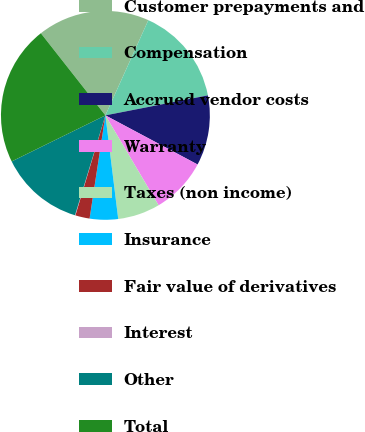Convert chart to OTSL. <chart><loc_0><loc_0><loc_500><loc_500><pie_chart><fcel>Customer prepayments and<fcel>Compensation<fcel>Accrued vendor costs<fcel>Warranty<fcel>Taxes (non income)<fcel>Insurance<fcel>Fair value of derivatives<fcel>Interest<fcel>Other<fcel>Total<nl><fcel>17.34%<fcel>15.18%<fcel>10.86%<fcel>8.7%<fcel>6.54%<fcel>4.38%<fcel>2.22%<fcel>0.06%<fcel>13.02%<fcel>21.66%<nl></chart> 